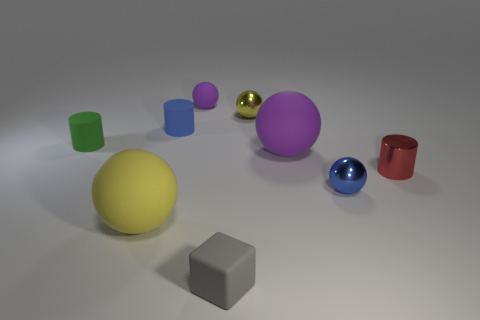What material is the small cube?
Your answer should be compact. Rubber. The other small cylinder that is made of the same material as the tiny blue cylinder is what color?
Provide a short and direct response. Green. Does the blue ball have the same material as the purple sphere that is on the left side of the large purple rubber thing?
Offer a very short reply. No. What number of purple objects are made of the same material as the tiny cube?
Give a very brief answer. 2. What shape is the yellow object in front of the small blue shiny sphere?
Provide a succinct answer. Sphere. Do the red cylinder that is on the right side of the green object and the yellow thing that is behind the blue rubber cylinder have the same material?
Offer a very short reply. Yes. Is there a big red object of the same shape as the tiny blue metal thing?
Ensure brevity in your answer.  No. What number of objects are either large spheres that are left of the gray block or tiny yellow spheres?
Provide a succinct answer. 2. Are there more cylinders behind the metal cylinder than green matte cylinders that are in front of the green rubber cylinder?
Provide a short and direct response. Yes. What number of metallic objects are either yellow balls or big purple spheres?
Ensure brevity in your answer.  1. 